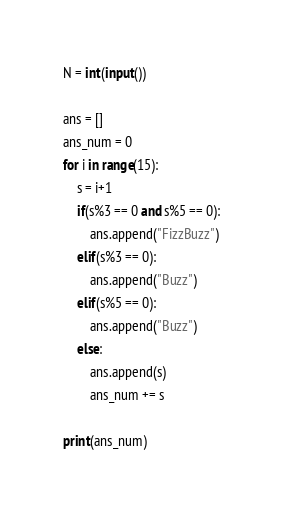<code> <loc_0><loc_0><loc_500><loc_500><_Python_>N = int(input())

ans = []
ans_num = 0
for i in range(15):
    s = i+1
    if(s%3 == 0 and s%5 == 0):
        ans.append("FizzBuzz")
    elif(s%3 == 0):
        ans.append("Buzz")
    elif(s%5 == 0):
        ans.append("Buzz")
    else:
        ans.append(s) 
        ans_num += s

print(ans_num)
</code> 